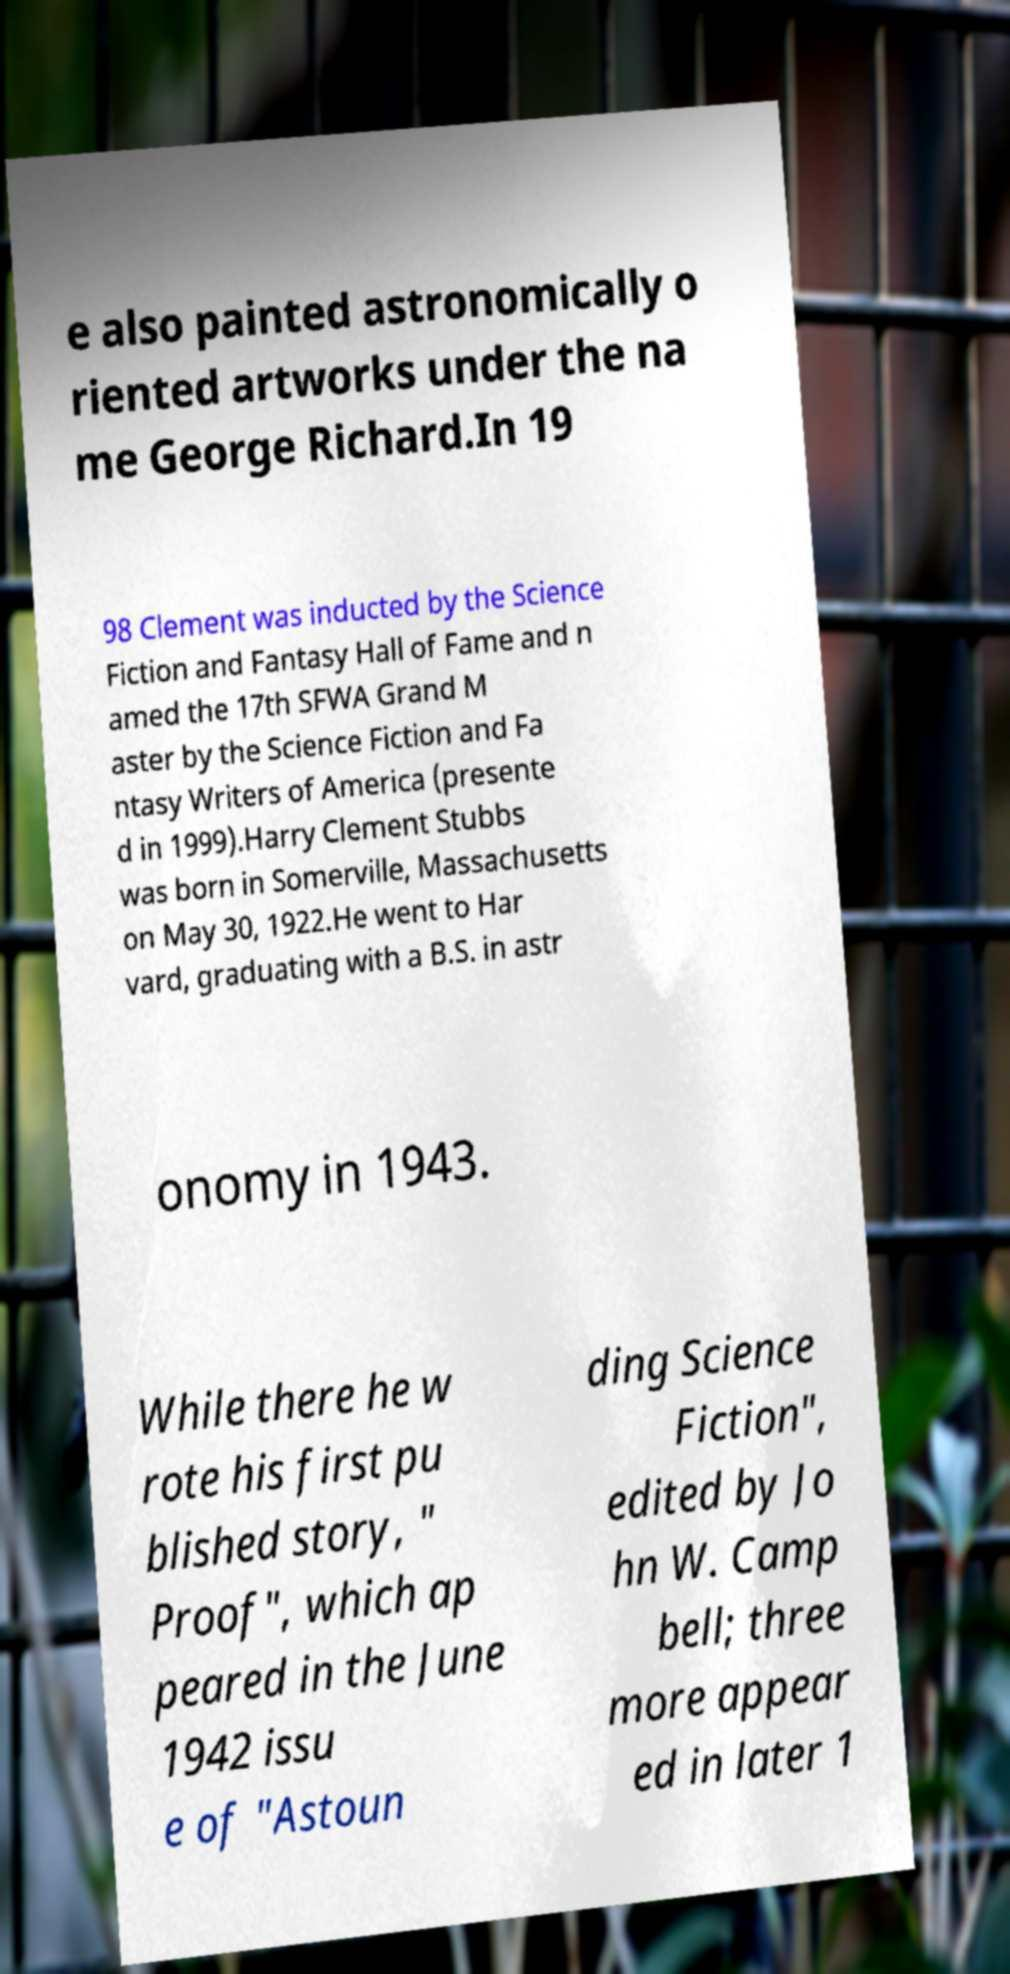Please read and relay the text visible in this image. What does it say? e also painted astronomically o riented artworks under the na me George Richard.In 19 98 Clement was inducted by the Science Fiction and Fantasy Hall of Fame and n amed the 17th SFWA Grand M aster by the Science Fiction and Fa ntasy Writers of America (presente d in 1999).Harry Clement Stubbs was born in Somerville, Massachusetts on May 30, 1922.He went to Har vard, graduating with a B.S. in astr onomy in 1943. While there he w rote his first pu blished story, " Proof", which ap peared in the June 1942 issu e of "Astoun ding Science Fiction", edited by Jo hn W. Camp bell; three more appear ed in later 1 